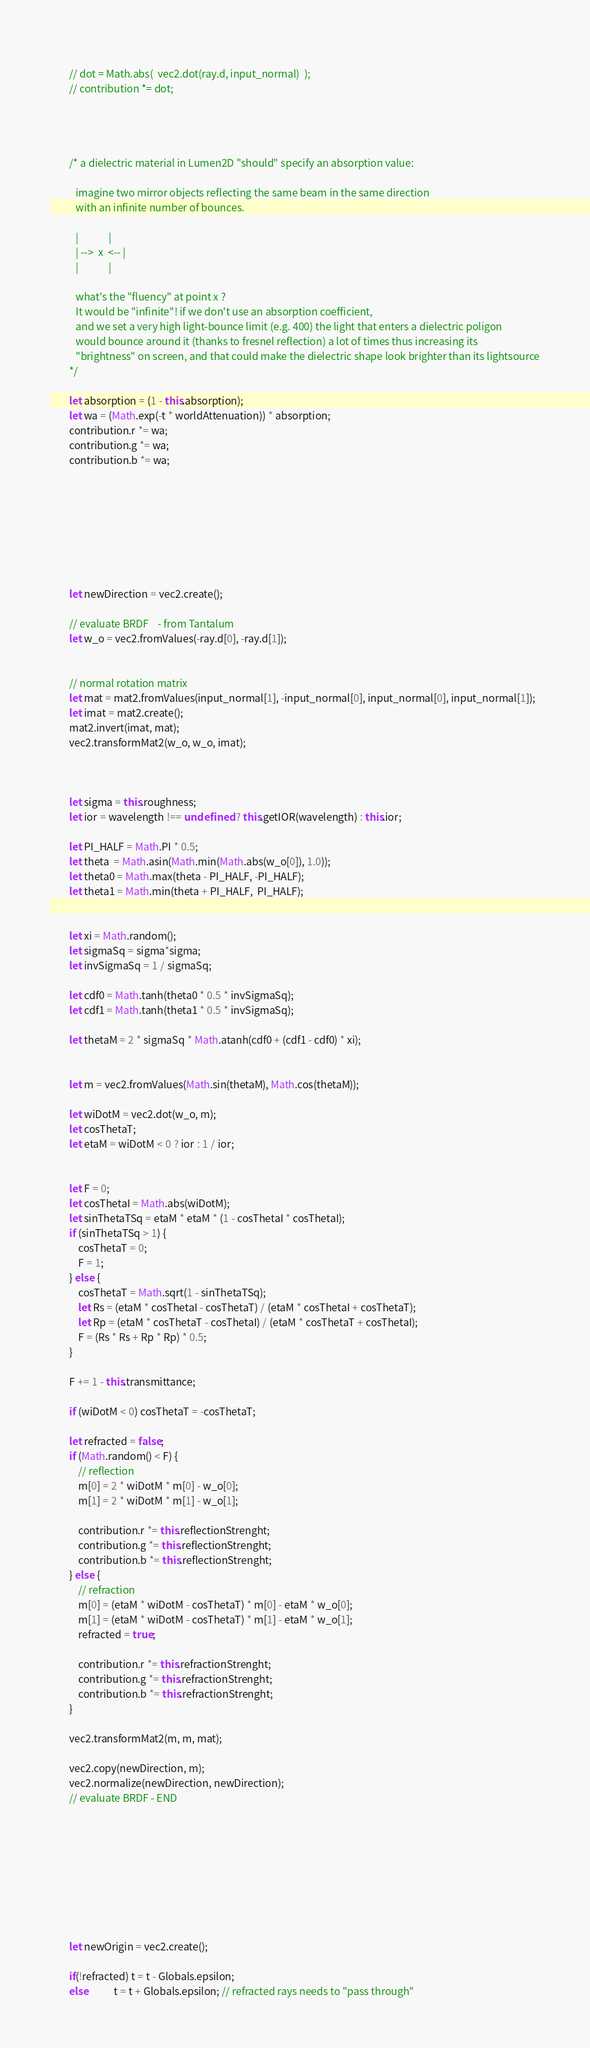Convert code to text. <code><loc_0><loc_0><loc_500><loc_500><_JavaScript_>    
        // dot = Math.abs(  vec2.dot(ray.d, input_normal)  );
        // contribution *= dot; 




        /* a dielectric material in Lumen2D "should" specify an absorption value:
           
           imagine two mirror objects reflecting the same beam in the same direction
           with an infinite number of bounces. 
           
           |             |
           | -->  x  <-- |
           |             |
   
           what's the "fluency" at point x ?
           It would be "infinite"! if we don't use an absorption coefficient,
           and we set a very high light-bounce limit (e.g. 400) the light that enters a dielectric poligon
           would bounce around it (thanks to fresnel reflection) a lot of times thus increasing its
           "brightness" on screen, and that could make the dielectric shape look brighter than its lightsource
        */

        let absorption = (1 - this.absorption);
        let wa = (Math.exp(-t * worldAttenuation)) * absorption;
        contribution.r *= wa;
        contribution.g *= wa;
        contribution.b *= wa;








        let newDirection = vec2.create();

        // evaluate BRDF    - from Tantalum
        let w_o = vec2.fromValues(-ray.d[0], -ray.d[1]);


        // normal rotation matrix
        let mat = mat2.fromValues(input_normal[1], -input_normal[0], input_normal[0], input_normal[1]);
        let imat = mat2.create();
        mat2.invert(imat, mat);
        vec2.transformMat2(w_o, w_o, imat);



        let sigma = this.roughness;
        let ior = wavelength !== undefined ? this.getIOR(wavelength) : this.ior;

        let PI_HALF = Math.PI * 0.5;
        let theta  = Math.asin(Math.min(Math.abs(w_o[0]), 1.0));
        let theta0 = Math.max(theta - PI_HALF, -PI_HALF);
        let theta1 = Math.min(theta + PI_HALF,  PI_HALF);


        let xi = Math.random();
        let sigmaSq = sigma*sigma;
        let invSigmaSq = 1 / sigmaSq;

        let cdf0 = Math.tanh(theta0 * 0.5 * invSigmaSq);
        let cdf1 = Math.tanh(theta1 * 0.5 * invSigmaSq);

        let thetaM = 2 * sigmaSq * Math.atanh(cdf0 + (cdf1 - cdf0) * xi);  


        let m = vec2.fromValues(Math.sin(thetaM), Math.cos(thetaM));

        let wiDotM = vec2.dot(w_o, m);
        let cosThetaT;
        let etaM = wiDotM < 0 ? ior : 1 / ior;


        let F = 0;
        let cosThetaI = Math.abs(wiDotM);
        let sinThetaTSq = etaM * etaM * (1 - cosThetaI * cosThetaI);
        if (sinThetaTSq > 1) {
            cosThetaT = 0;
            F = 1;
        } else {
            cosThetaT = Math.sqrt(1 - sinThetaTSq);
            let Rs = (etaM * cosThetaI - cosThetaT) / (etaM * cosThetaI + cosThetaT);
            let Rp = (etaM * cosThetaT - cosThetaI) / (etaM * cosThetaT + cosThetaI);
            F = (Rs * Rs + Rp * Rp) * 0.5;            
        }

        F += 1 - this.transmittance;

        if (wiDotM < 0) cosThetaT = -cosThetaT;

        let refracted = false;
        if (Math.random() < F) {
            // reflection
            m[0] = 2 * wiDotM * m[0] - w_o[0];
            m[1] = 2 * wiDotM * m[1] - w_o[1];

            contribution.r *= this.reflectionStrenght;
            contribution.g *= this.reflectionStrenght;
            contribution.b *= this.reflectionStrenght;
        } else {
            // refraction
            m[0] = (etaM * wiDotM - cosThetaT) * m[0] - etaM * w_o[0];            
            m[1] = (etaM * wiDotM - cosThetaT) * m[1] - etaM * w_o[1];      
            refracted = true;

            contribution.r *= this.refractionStrenght;
            contribution.g *= this.refractionStrenght;
            contribution.b *= this.refractionStrenght;
        }

        vec2.transformMat2(m, m, mat);

        vec2.copy(newDirection, m);
        vec2.normalize(newDirection, newDirection);
        // evaluate BRDF - END

        







        let newOrigin = vec2.create();

        if(!refracted) t = t - Globals.epsilon;
        else           t = t + Globals.epsilon; // refracted rays needs to "pass through"
</code> 